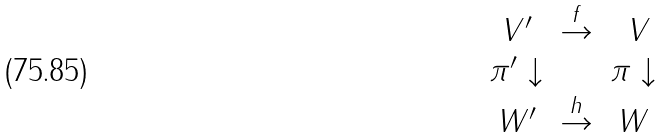<formula> <loc_0><loc_0><loc_500><loc_500>\begin{array} { c c c } V ^ { \prime } & \stackrel { f } \to & \ V \\ \pi ^ { \prime } \downarrow & & \pi \downarrow \\ W ^ { \prime } & \stackrel { h } \to & W \end{array}</formula> 